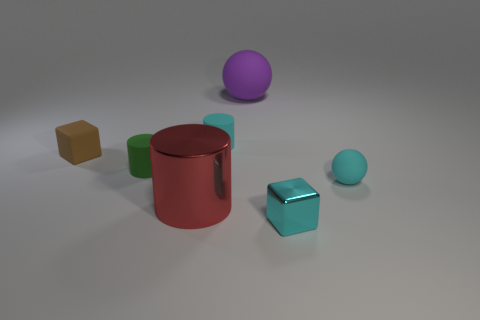Subtract all big cylinders. How many cylinders are left? 2 Add 2 cyan cylinders. How many objects exist? 9 Subtract all purple balls. How many balls are left? 1 Subtract 2 spheres. How many spheres are left? 0 Add 5 tiny brown matte blocks. How many tiny brown matte blocks exist? 6 Subtract 1 cyan balls. How many objects are left? 6 Subtract all blocks. How many objects are left? 5 Subtract all red blocks. Subtract all yellow balls. How many blocks are left? 2 Subtract all red blocks. How many cyan cylinders are left? 1 Subtract all tiny cyan spheres. Subtract all small rubber things. How many objects are left? 2 